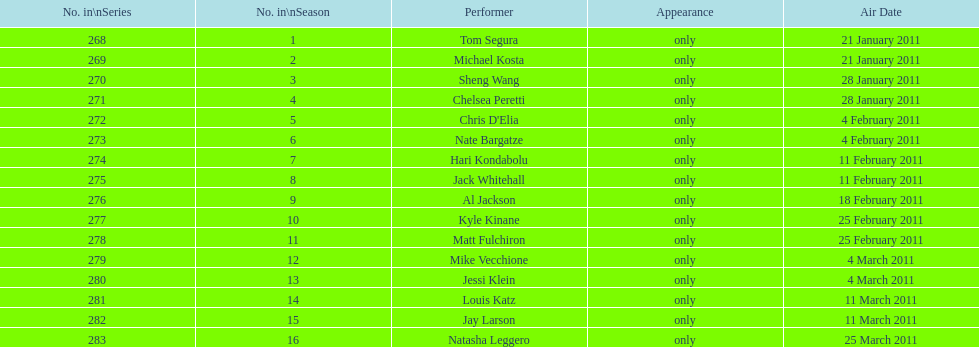What were the total number of air dates in february? 7. 